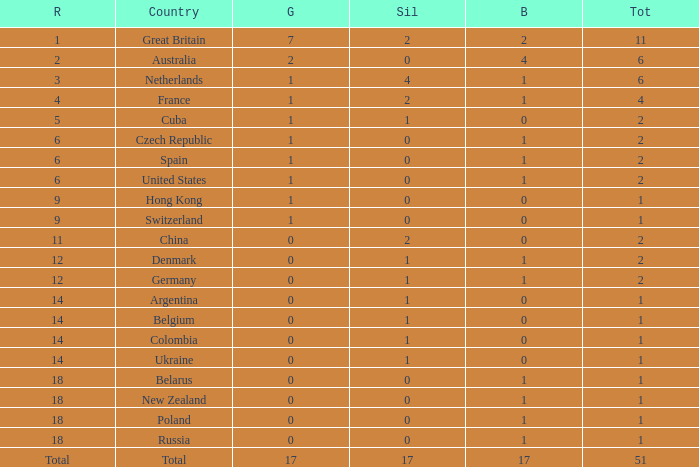Tell me the rank for bronze less than 17 and gold less than 1 11.0. 